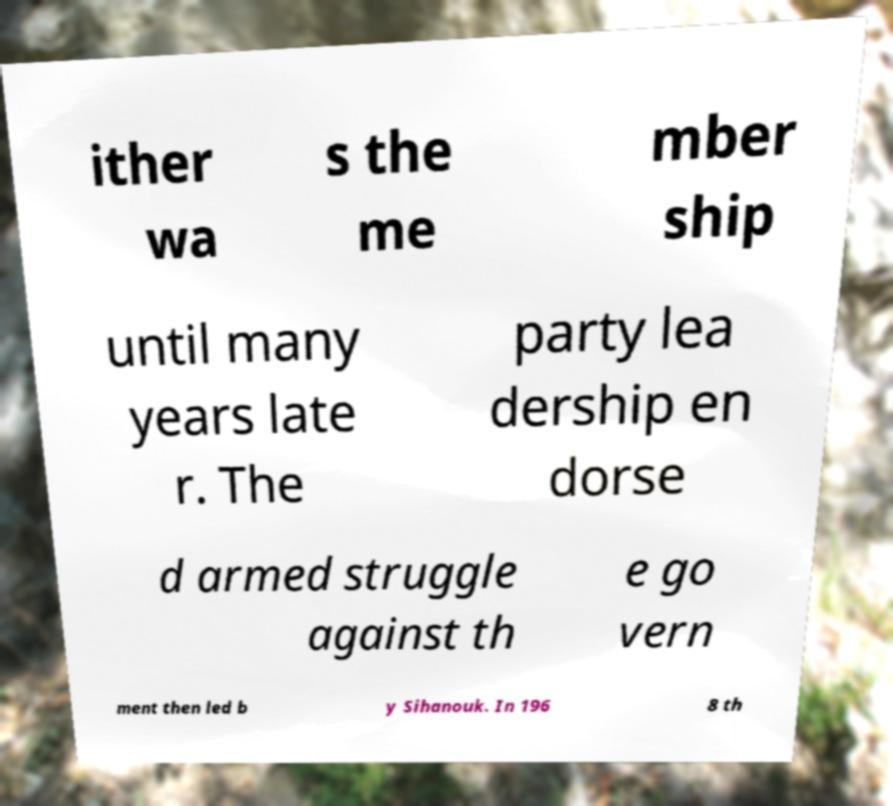Can you accurately transcribe the text from the provided image for me? ither wa s the me mber ship until many years late r. The party lea dership en dorse d armed struggle against th e go vern ment then led b y Sihanouk. In 196 8 th 